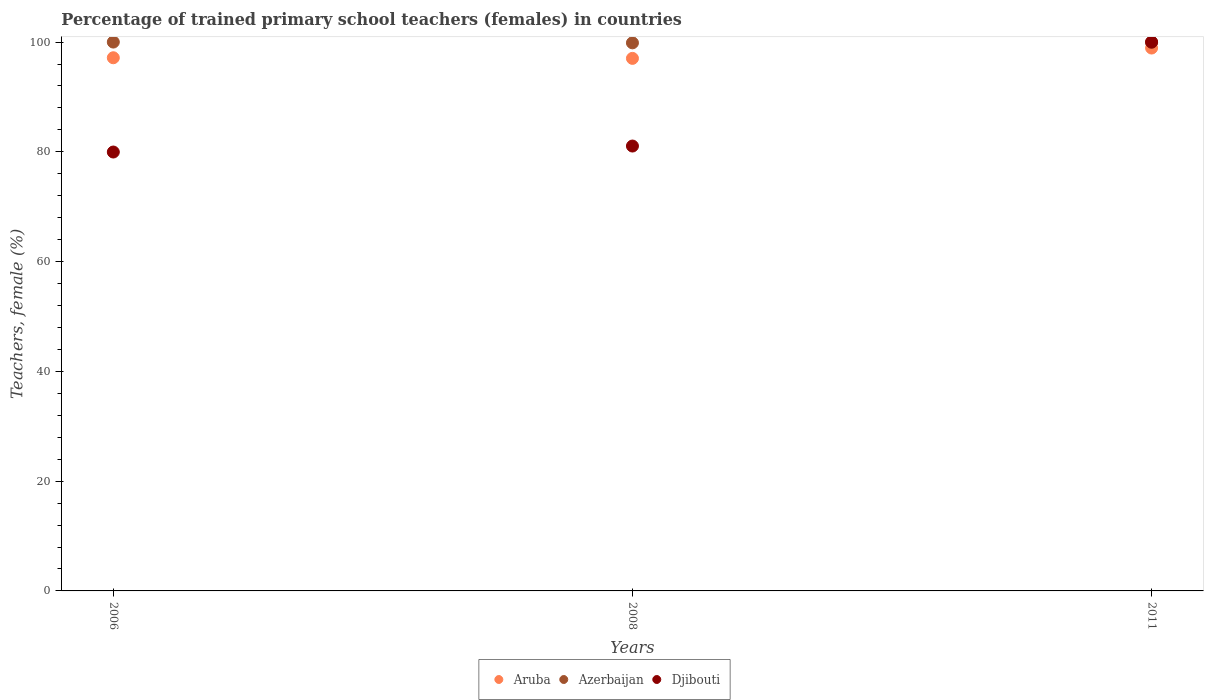Is the number of dotlines equal to the number of legend labels?
Provide a short and direct response. Yes. What is the percentage of trained primary school teachers (females) in Aruba in 2006?
Offer a terse response. 97.14. Across all years, what is the minimum percentage of trained primary school teachers (females) in Aruba?
Your response must be concise. 97.03. In which year was the percentage of trained primary school teachers (females) in Djibouti minimum?
Offer a very short reply. 2006. What is the total percentage of trained primary school teachers (females) in Aruba in the graph?
Provide a short and direct response. 293.09. What is the difference between the percentage of trained primary school teachers (females) in Azerbaijan in 2006 and that in 2008?
Make the answer very short. 0.14. What is the difference between the percentage of trained primary school teachers (females) in Aruba in 2011 and the percentage of trained primary school teachers (females) in Azerbaijan in 2008?
Make the answer very short. -0.95. What is the average percentage of trained primary school teachers (females) in Djibouti per year?
Offer a terse response. 87.01. In the year 2011, what is the difference between the percentage of trained primary school teachers (females) in Azerbaijan and percentage of trained primary school teachers (females) in Aruba?
Provide a short and direct response. 1.05. What is the ratio of the percentage of trained primary school teachers (females) in Aruba in 2006 to that in 2011?
Offer a very short reply. 0.98. Is the difference between the percentage of trained primary school teachers (females) in Azerbaijan in 2006 and 2008 greater than the difference between the percentage of trained primary school teachers (females) in Aruba in 2006 and 2008?
Make the answer very short. Yes. What is the difference between the highest and the second highest percentage of trained primary school teachers (females) in Azerbaijan?
Provide a short and direct response. 0.04. What is the difference between the highest and the lowest percentage of trained primary school teachers (females) in Azerbaijan?
Your answer should be very brief. 0.14. Is the sum of the percentage of trained primary school teachers (females) in Azerbaijan in 2006 and 2008 greater than the maximum percentage of trained primary school teachers (females) in Djibouti across all years?
Offer a very short reply. Yes. Is it the case that in every year, the sum of the percentage of trained primary school teachers (females) in Aruba and percentage of trained primary school teachers (females) in Djibouti  is greater than the percentage of trained primary school teachers (females) in Azerbaijan?
Your answer should be compact. Yes. Is the percentage of trained primary school teachers (females) in Aruba strictly less than the percentage of trained primary school teachers (females) in Djibouti over the years?
Ensure brevity in your answer.  No. How many dotlines are there?
Your answer should be very brief. 3. What is the difference between two consecutive major ticks on the Y-axis?
Make the answer very short. 20. Does the graph contain any zero values?
Your answer should be compact. No. Does the graph contain grids?
Provide a short and direct response. No. Where does the legend appear in the graph?
Your response must be concise. Bottom center. How many legend labels are there?
Your answer should be compact. 3. How are the legend labels stacked?
Your answer should be compact. Horizontal. What is the title of the graph?
Offer a very short reply. Percentage of trained primary school teachers (females) in countries. Does "Qatar" appear as one of the legend labels in the graph?
Keep it short and to the point. No. What is the label or title of the Y-axis?
Provide a short and direct response. Teachers, female (%). What is the Teachers, female (%) in Aruba in 2006?
Your answer should be compact. 97.14. What is the Teachers, female (%) in Djibouti in 2006?
Ensure brevity in your answer.  79.97. What is the Teachers, female (%) of Aruba in 2008?
Provide a short and direct response. 97.03. What is the Teachers, female (%) of Azerbaijan in 2008?
Make the answer very short. 99.86. What is the Teachers, female (%) in Djibouti in 2008?
Provide a short and direct response. 81.06. What is the Teachers, female (%) of Aruba in 2011?
Give a very brief answer. 98.91. What is the Teachers, female (%) in Azerbaijan in 2011?
Your response must be concise. 99.96. Across all years, what is the maximum Teachers, female (%) in Aruba?
Provide a succinct answer. 98.91. Across all years, what is the maximum Teachers, female (%) of Azerbaijan?
Give a very brief answer. 100. Across all years, what is the maximum Teachers, female (%) in Djibouti?
Your answer should be compact. 100. Across all years, what is the minimum Teachers, female (%) of Aruba?
Make the answer very short. 97.03. Across all years, what is the minimum Teachers, female (%) of Azerbaijan?
Your response must be concise. 99.86. Across all years, what is the minimum Teachers, female (%) of Djibouti?
Your response must be concise. 79.97. What is the total Teachers, female (%) of Aruba in the graph?
Provide a succinct answer. 293.09. What is the total Teachers, female (%) of Azerbaijan in the graph?
Your answer should be compact. 299.82. What is the total Teachers, female (%) in Djibouti in the graph?
Offer a terse response. 261.02. What is the difference between the Teachers, female (%) of Aruba in 2006 and that in 2008?
Your response must be concise. 0.11. What is the difference between the Teachers, female (%) in Azerbaijan in 2006 and that in 2008?
Offer a terse response. 0.14. What is the difference between the Teachers, female (%) of Djibouti in 2006 and that in 2008?
Keep it short and to the point. -1.09. What is the difference between the Teachers, female (%) of Aruba in 2006 and that in 2011?
Offer a terse response. -1.77. What is the difference between the Teachers, female (%) of Azerbaijan in 2006 and that in 2011?
Offer a very short reply. 0.04. What is the difference between the Teachers, female (%) in Djibouti in 2006 and that in 2011?
Keep it short and to the point. -20.03. What is the difference between the Teachers, female (%) of Aruba in 2008 and that in 2011?
Provide a succinct answer. -1.88. What is the difference between the Teachers, female (%) of Azerbaijan in 2008 and that in 2011?
Offer a very short reply. -0.1. What is the difference between the Teachers, female (%) of Djibouti in 2008 and that in 2011?
Your response must be concise. -18.94. What is the difference between the Teachers, female (%) of Aruba in 2006 and the Teachers, female (%) of Azerbaijan in 2008?
Your response must be concise. -2.72. What is the difference between the Teachers, female (%) in Aruba in 2006 and the Teachers, female (%) in Djibouti in 2008?
Your response must be concise. 16.09. What is the difference between the Teachers, female (%) in Azerbaijan in 2006 and the Teachers, female (%) in Djibouti in 2008?
Offer a very short reply. 18.94. What is the difference between the Teachers, female (%) in Aruba in 2006 and the Teachers, female (%) in Azerbaijan in 2011?
Your answer should be compact. -2.82. What is the difference between the Teachers, female (%) of Aruba in 2006 and the Teachers, female (%) of Djibouti in 2011?
Provide a succinct answer. -2.86. What is the difference between the Teachers, female (%) in Azerbaijan in 2006 and the Teachers, female (%) in Djibouti in 2011?
Give a very brief answer. 0. What is the difference between the Teachers, female (%) of Aruba in 2008 and the Teachers, female (%) of Azerbaijan in 2011?
Ensure brevity in your answer.  -2.93. What is the difference between the Teachers, female (%) of Aruba in 2008 and the Teachers, female (%) of Djibouti in 2011?
Your response must be concise. -2.97. What is the difference between the Teachers, female (%) in Azerbaijan in 2008 and the Teachers, female (%) in Djibouti in 2011?
Your response must be concise. -0.14. What is the average Teachers, female (%) in Aruba per year?
Give a very brief answer. 97.7. What is the average Teachers, female (%) of Azerbaijan per year?
Provide a succinct answer. 99.94. What is the average Teachers, female (%) of Djibouti per year?
Your answer should be compact. 87.01. In the year 2006, what is the difference between the Teachers, female (%) of Aruba and Teachers, female (%) of Azerbaijan?
Offer a very short reply. -2.86. In the year 2006, what is the difference between the Teachers, female (%) of Aruba and Teachers, female (%) of Djibouti?
Provide a succinct answer. 17.18. In the year 2006, what is the difference between the Teachers, female (%) of Azerbaijan and Teachers, female (%) of Djibouti?
Offer a very short reply. 20.03. In the year 2008, what is the difference between the Teachers, female (%) of Aruba and Teachers, female (%) of Azerbaijan?
Provide a succinct answer. -2.83. In the year 2008, what is the difference between the Teachers, female (%) of Aruba and Teachers, female (%) of Djibouti?
Provide a short and direct response. 15.97. In the year 2008, what is the difference between the Teachers, female (%) in Azerbaijan and Teachers, female (%) in Djibouti?
Provide a short and direct response. 18.8. In the year 2011, what is the difference between the Teachers, female (%) of Aruba and Teachers, female (%) of Azerbaijan?
Your response must be concise. -1.05. In the year 2011, what is the difference between the Teachers, female (%) in Aruba and Teachers, female (%) in Djibouti?
Provide a short and direct response. -1.09. In the year 2011, what is the difference between the Teachers, female (%) of Azerbaijan and Teachers, female (%) of Djibouti?
Offer a very short reply. -0.04. What is the ratio of the Teachers, female (%) of Azerbaijan in 2006 to that in 2008?
Offer a very short reply. 1. What is the ratio of the Teachers, female (%) in Djibouti in 2006 to that in 2008?
Offer a terse response. 0.99. What is the ratio of the Teachers, female (%) in Aruba in 2006 to that in 2011?
Offer a very short reply. 0.98. What is the ratio of the Teachers, female (%) of Djibouti in 2006 to that in 2011?
Your response must be concise. 0.8. What is the ratio of the Teachers, female (%) in Aruba in 2008 to that in 2011?
Make the answer very short. 0.98. What is the ratio of the Teachers, female (%) of Azerbaijan in 2008 to that in 2011?
Provide a succinct answer. 1. What is the ratio of the Teachers, female (%) of Djibouti in 2008 to that in 2011?
Your answer should be very brief. 0.81. What is the difference between the highest and the second highest Teachers, female (%) in Aruba?
Provide a short and direct response. 1.77. What is the difference between the highest and the second highest Teachers, female (%) of Azerbaijan?
Make the answer very short. 0.04. What is the difference between the highest and the second highest Teachers, female (%) of Djibouti?
Offer a very short reply. 18.94. What is the difference between the highest and the lowest Teachers, female (%) of Aruba?
Your answer should be very brief. 1.88. What is the difference between the highest and the lowest Teachers, female (%) in Azerbaijan?
Your answer should be very brief. 0.14. What is the difference between the highest and the lowest Teachers, female (%) of Djibouti?
Provide a short and direct response. 20.03. 